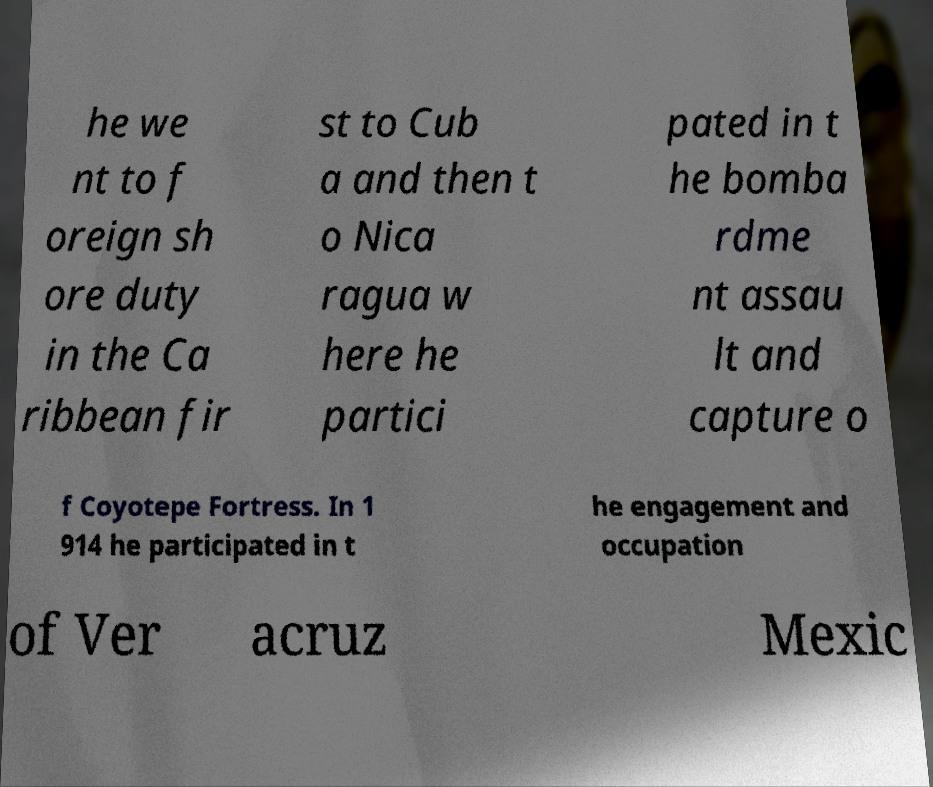Could you assist in decoding the text presented in this image and type it out clearly? he we nt to f oreign sh ore duty in the Ca ribbean fir st to Cub a and then t o Nica ragua w here he partici pated in t he bomba rdme nt assau lt and capture o f Coyotepe Fortress. In 1 914 he participated in t he engagement and occupation of Ver acruz Mexic 